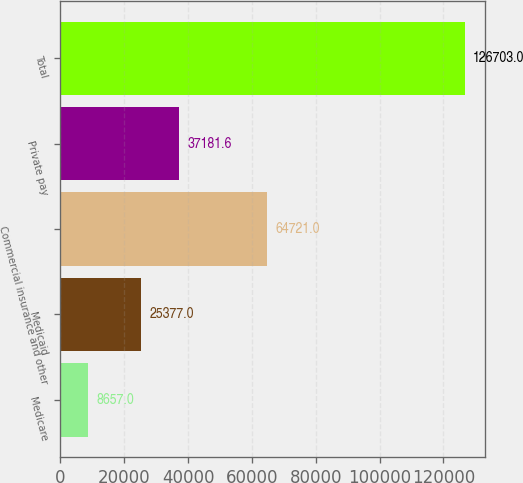Convert chart to OTSL. <chart><loc_0><loc_0><loc_500><loc_500><bar_chart><fcel>Medicare<fcel>Medicaid<fcel>Commercial insurance and other<fcel>Private pay<fcel>Total<nl><fcel>8657<fcel>25377<fcel>64721<fcel>37181.6<fcel>126703<nl></chart> 